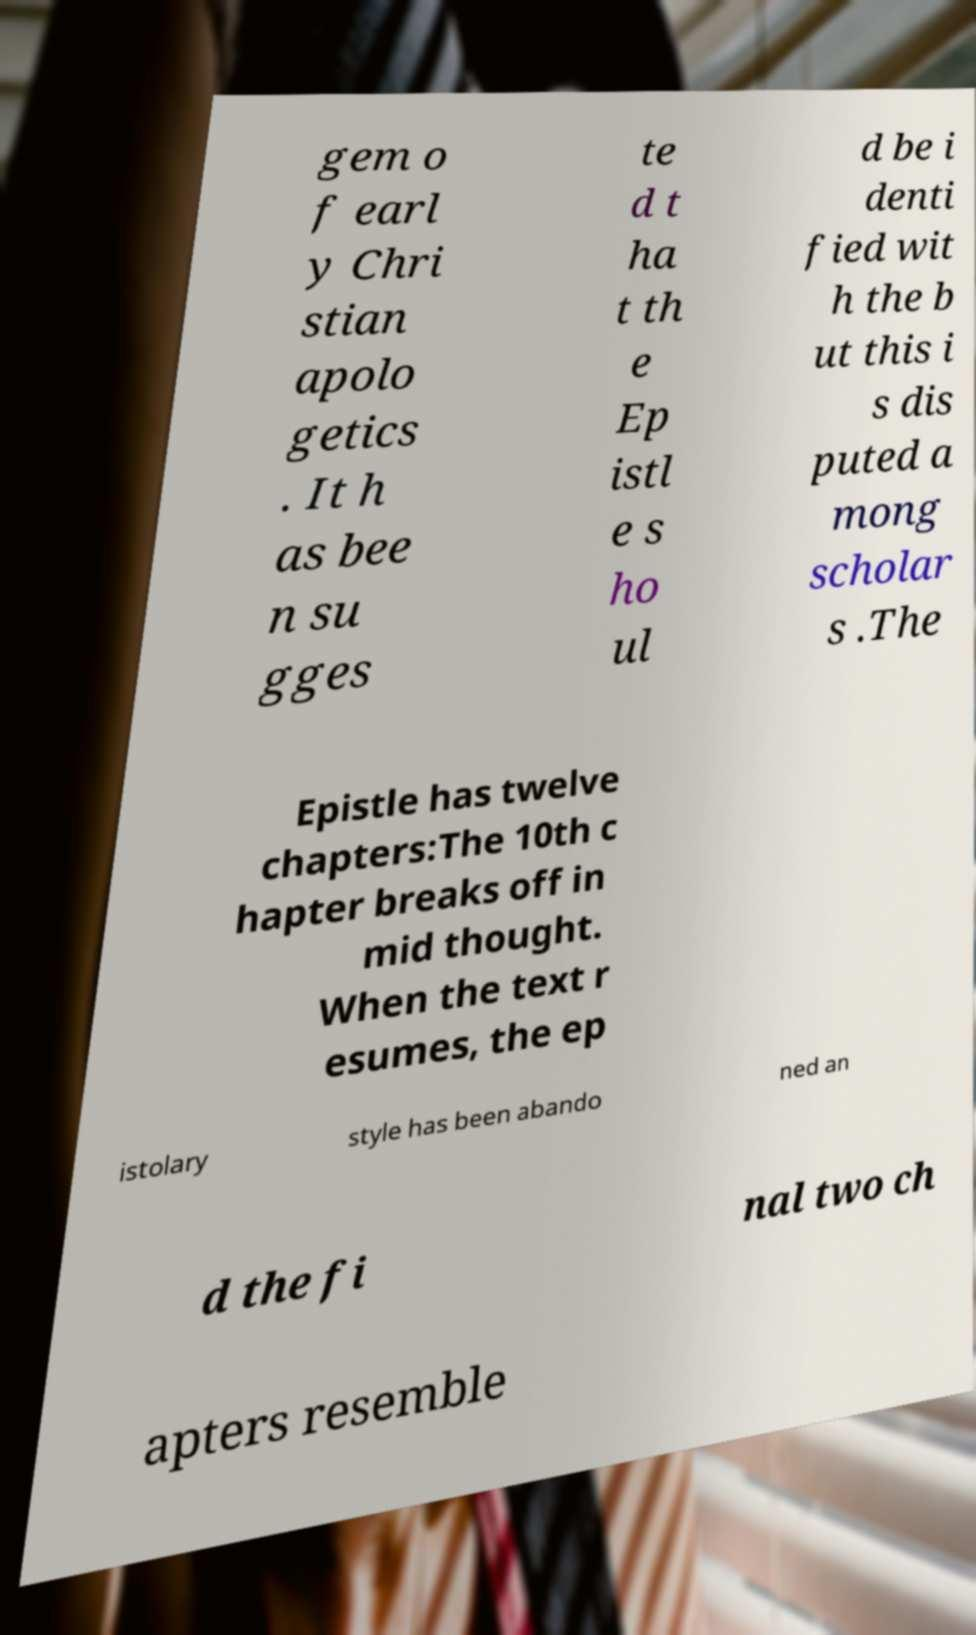Please identify and transcribe the text found in this image. gem o f earl y Chri stian apolo getics . It h as bee n su gges te d t ha t th e Ep istl e s ho ul d be i denti fied wit h the b ut this i s dis puted a mong scholar s .The Epistle has twelve chapters:The 10th c hapter breaks off in mid thought. When the text r esumes, the ep istolary style has been abando ned an d the fi nal two ch apters resemble 